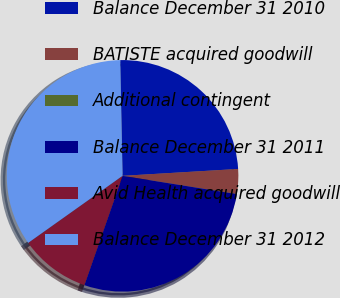Convert chart. <chart><loc_0><loc_0><loc_500><loc_500><pie_chart><fcel>Balance December 31 2010<fcel>BATISTE acquired goodwill<fcel>Additional contingent<fcel>Balance December 31 2011<fcel>Avid Health acquired goodwill<fcel>Balance December 31 2012<nl><fcel>24.38%<fcel>3.46%<fcel>0.01%<fcel>27.83%<fcel>9.82%<fcel>34.51%<nl></chart> 